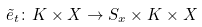<formula> <loc_0><loc_0><loc_500><loc_500>\tilde { e } _ { t } \colon K \times X \to S _ { x } \times K \times X</formula> 